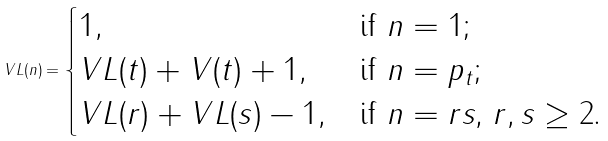Convert formula to latex. <formula><loc_0><loc_0><loc_500><loc_500>V L ( n ) = \begin{cases} 1 , & \text {if $n=1$;} \\ V L ( t ) + V ( t ) + 1 , & \text {if $n=p_{t}$;} \\ V L ( r ) + V L ( s ) - 1 , & \text {if $n=rs$, $r,s \geq 2$.} \end{cases}</formula> 